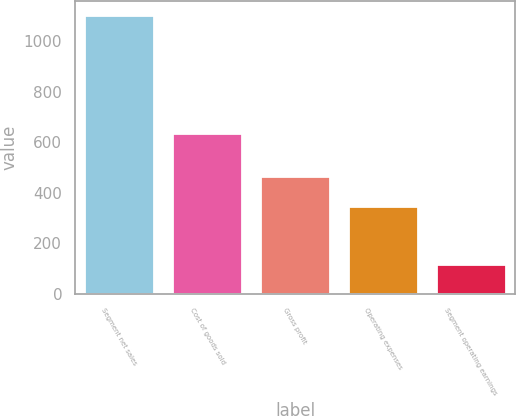Convert chart. <chart><loc_0><loc_0><loc_500><loc_500><bar_chart><fcel>Segment net sales<fcel>Cost of goods sold<fcel>Gross profit<fcel>Operating expenses<fcel>Segment operating earnings<nl><fcel>1104<fcel>636.5<fcel>467.5<fcel>349.8<fcel>117.7<nl></chart> 